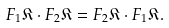Convert formula to latex. <formula><loc_0><loc_0><loc_500><loc_500>F _ { 1 } \mathfrak { K } \cdot F _ { 2 } \mathfrak { K } = F _ { 2 } \mathfrak { K } \cdot F _ { 1 } \mathfrak { K } .</formula> 